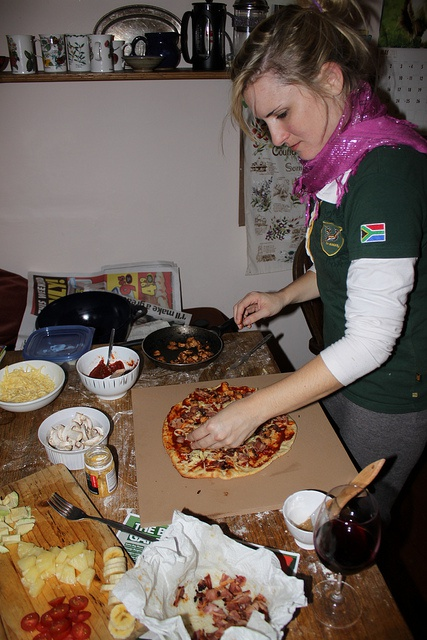Describe the objects in this image and their specific colors. I can see people in black, lightgray, and gray tones, dining table in black, maroon, and gray tones, wine glass in black, maroon, and gray tones, pizza in black, maroon, brown, gray, and tan tones, and bowl in black, gray, navy, and darkgreen tones in this image. 